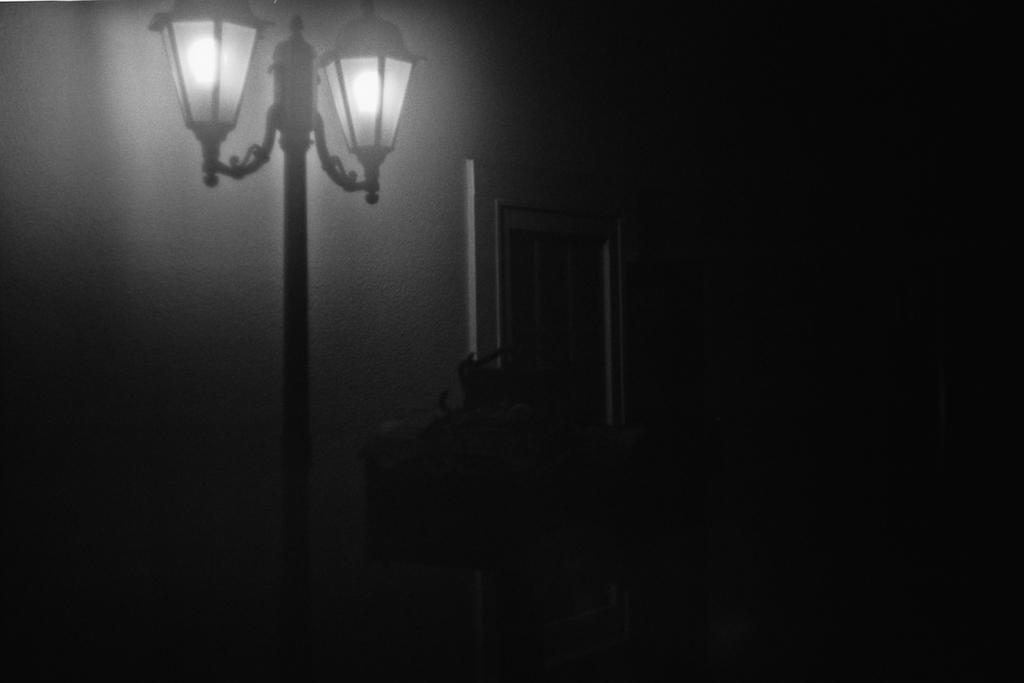What object can be seen in the image that provides light? There is a lamp in the image. What feature of the room is visible in the image? There is a window in the image. How would you describe the overall lighting in the room based on the image? The background of the image is dark, suggesting that the room may not be well-lit. What is the price of the bikes visible in the image? There are no bikes present in the image, so it is not possible to determine their price. 